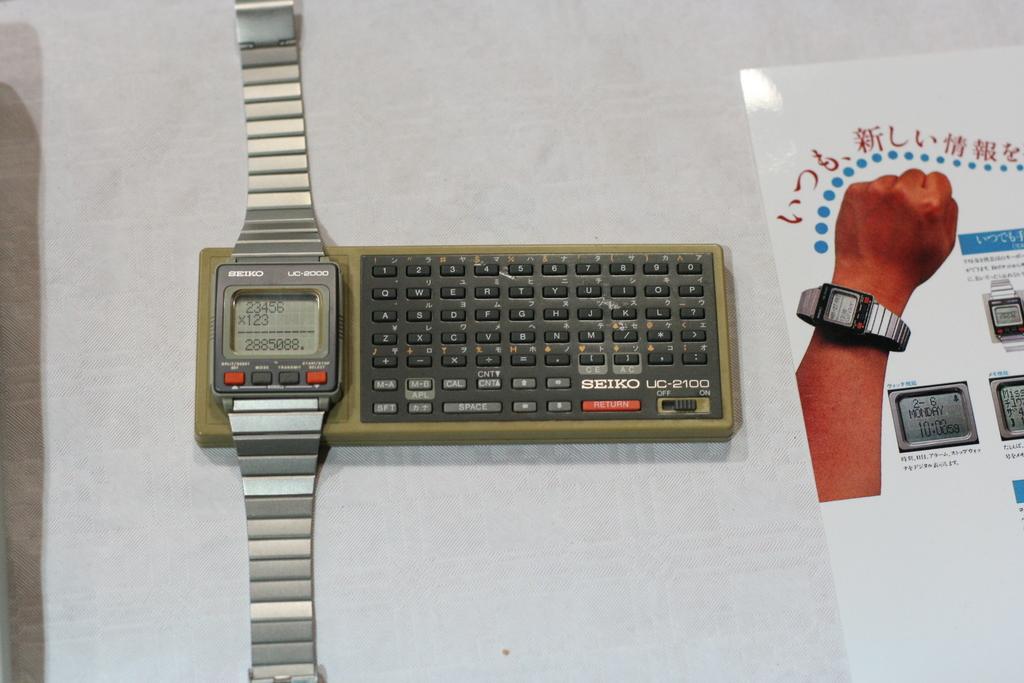What ttype of watch is this?
Your answer should be very brief. Seiko. 